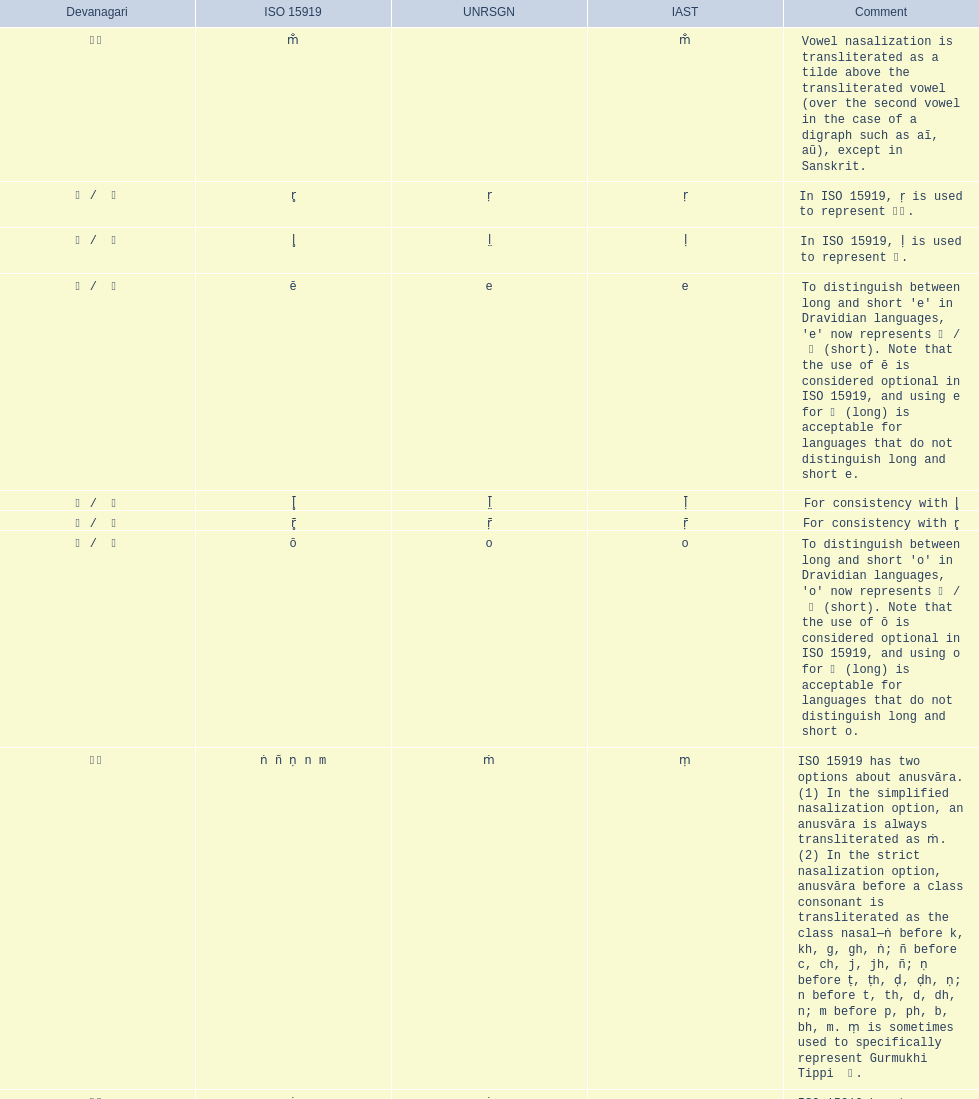This table shows the difference between how many transliterations? 3. 